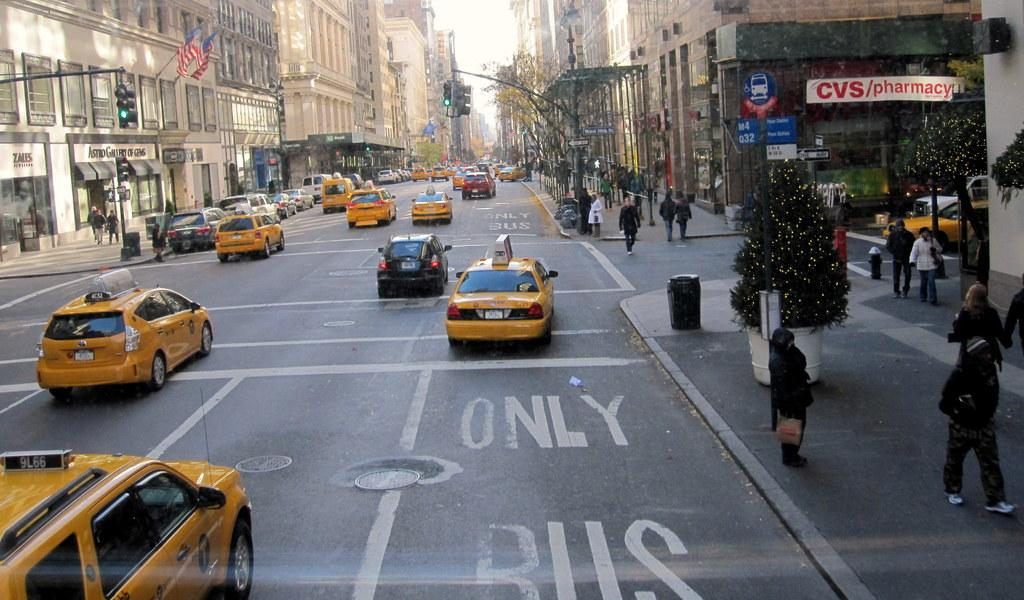<image>
Share a concise interpretation of the image provided. A taxicab drives in a lane that is marked as bus only. 